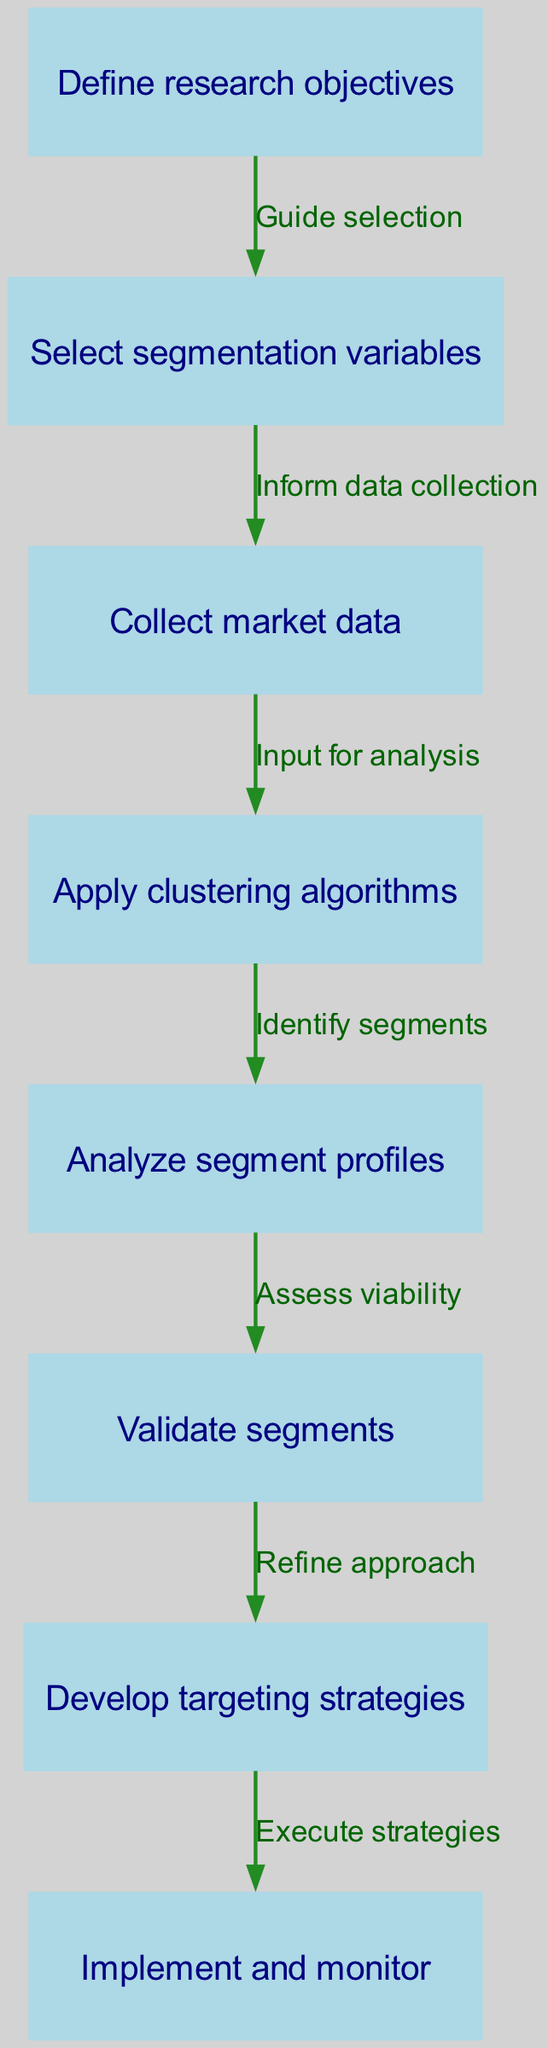What is the first step in the workflow? The first step is indicated by node 1, which states "Define research objectives." It is the starting point of the flowchart, laying the foundation for the subsequent steps.
Answer: Define research objectives How many nodes are present in the diagram? By counting the entries in the nodes list, we find there are 8 distinct nodes that represent different steps in the market segmentation analysis process.
Answer: 8 Which nodes are connected by the edge labeled "Refine approach"? The edge labeled "Refine approach" connects node 6 (Validate segments) with node 7 (Develop targeting strategies). This indicates a transition in focus from validation to strategy development.
Answer: Validate segments and Develop targeting strategies What is the relationship between "Collect market data" and "Input for analysis"? "Collect market data" (node 3) is the starting point of the edge that flows into "Apply clustering algorithms" (node 4) with the label "Input for analysis." This establishes that the collected data serves as the input for further analysis.
Answer: Input for analysis What stage follows after "Analyze segment profiles"? According to the flow of the diagram, the next stage after "Analyze segment profiles" (node 5) is "Validate segments" (node 6). This indicates that after analyzing the profiles, segments need to be validated before moving forward to targeting strategies.
Answer: Validate segments Which step involves executing strategies? The final step in the workflow is indicated by node 8, which states "Implement and monitor." This denotes that it is the conclusion of the process where the developed strategies are put into action.
Answer: Implement and monitor How many edges are there in the workflow? By counting the connections listed in the edges array, we can determine that there are 7 edges that represent the flow of actions between the various nodes in the diagram.
Answer: 7 What does "Identify segments" signify in the context of the workflow? "Identify segments" is represented by node 4, which implies that after applying clustering algorithms, the next logical step is to identify distinct market segments based on the analysis performed.
Answer: Identify segments What is the purpose of the step "Assess viability"? The step "Assess viability" (node 6) is important in the framework as it serves the purpose of evaluating and verifying that the identified segments are workable and suitable for targeting.
Answer: Assess viability 